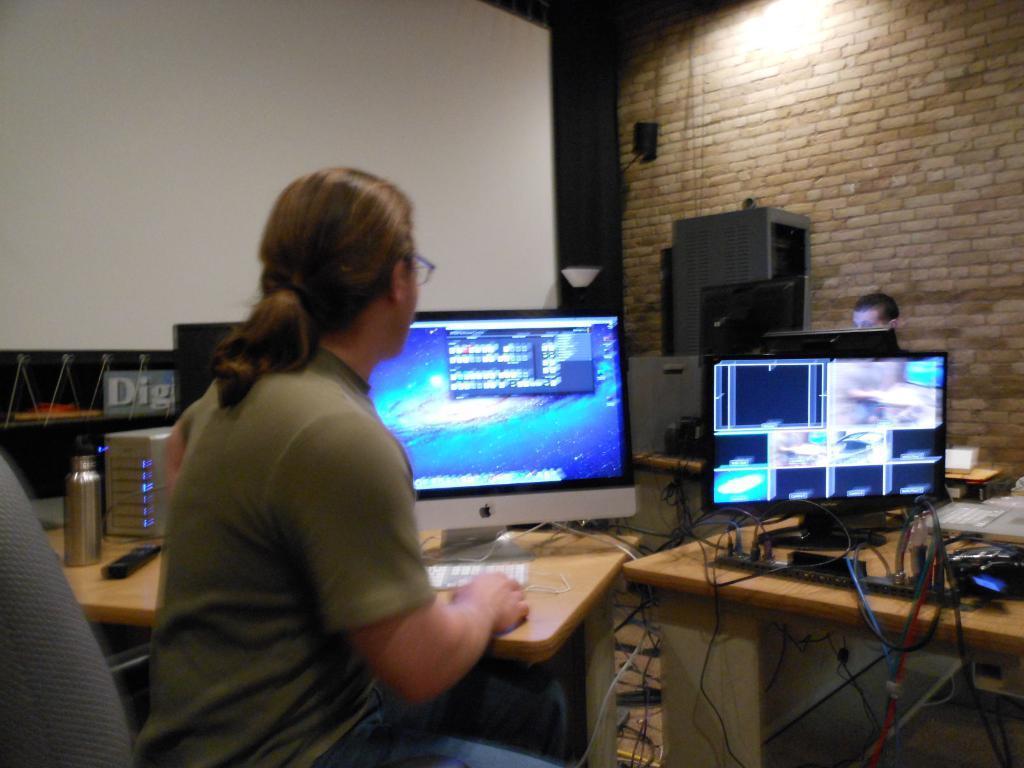Could you give a brief overview of what you see in this image? In this picture is a woman sitting in front of a monitor kept on the table. There is a water bottle and some other cables here. 